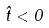Convert formula to latex. <formula><loc_0><loc_0><loc_500><loc_500>\hat { t } < 0</formula> 